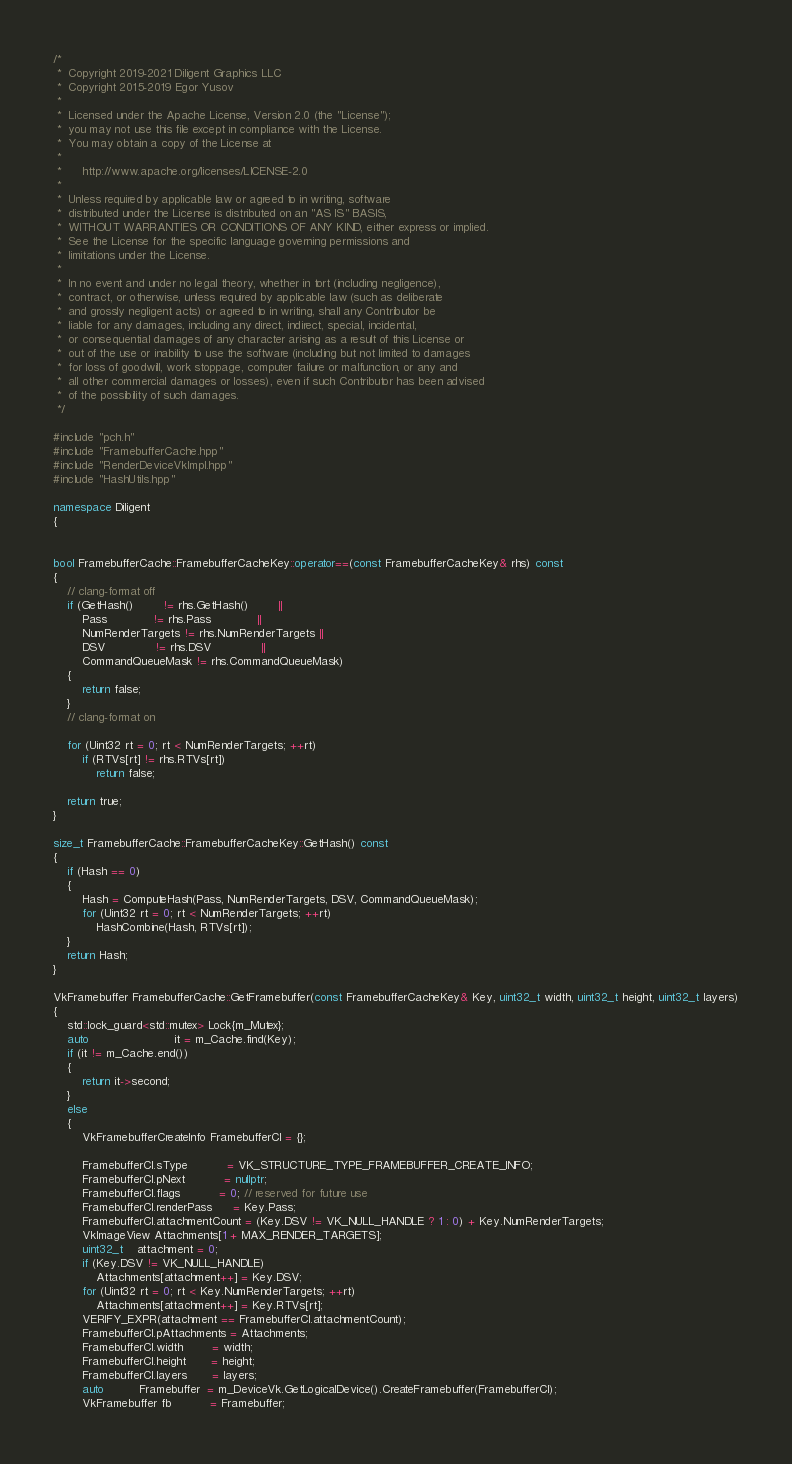Convert code to text. <code><loc_0><loc_0><loc_500><loc_500><_C++_>/*
 *  Copyright 2019-2021 Diligent Graphics LLC
 *  Copyright 2015-2019 Egor Yusov
 *  
 *  Licensed under the Apache License, Version 2.0 (the "License");
 *  you may not use this file except in compliance with the License.
 *  You may obtain a copy of the License at
 *  
 *      http://www.apache.org/licenses/LICENSE-2.0
 *  
 *  Unless required by applicable law or agreed to in writing, software
 *  distributed under the License is distributed on an "AS IS" BASIS,
 *  WITHOUT WARRANTIES OR CONDITIONS OF ANY KIND, either express or implied.
 *  See the License for the specific language governing permissions and
 *  limitations under the License.
 *
 *  In no event and under no legal theory, whether in tort (including negligence), 
 *  contract, or otherwise, unless required by applicable law (such as deliberate 
 *  and grossly negligent acts) or agreed to in writing, shall any Contributor be
 *  liable for any damages, including any direct, indirect, special, incidental, 
 *  or consequential damages of any character arising as a result of this License or 
 *  out of the use or inability to use the software (including but not limited to damages 
 *  for loss of goodwill, work stoppage, computer failure or malfunction, or any and 
 *  all other commercial damages or losses), even if such Contributor has been advised 
 *  of the possibility of such damages.
 */

#include "pch.h"
#include "FramebufferCache.hpp"
#include "RenderDeviceVkImpl.hpp"
#include "HashUtils.hpp"

namespace Diligent
{


bool FramebufferCache::FramebufferCacheKey::operator==(const FramebufferCacheKey& rhs) const
{
    // clang-format off
    if (GetHash()        != rhs.GetHash()        ||
        Pass             != rhs.Pass             ||
        NumRenderTargets != rhs.NumRenderTargets ||
        DSV              != rhs.DSV              ||
        CommandQueueMask != rhs.CommandQueueMask)
    {
        return false;
    }
    // clang-format on

    for (Uint32 rt = 0; rt < NumRenderTargets; ++rt)
        if (RTVs[rt] != rhs.RTVs[rt])
            return false;

    return true;
}

size_t FramebufferCache::FramebufferCacheKey::GetHash() const
{
    if (Hash == 0)
    {
        Hash = ComputeHash(Pass, NumRenderTargets, DSV, CommandQueueMask);
        for (Uint32 rt = 0; rt < NumRenderTargets; ++rt)
            HashCombine(Hash, RTVs[rt]);
    }
    return Hash;
}

VkFramebuffer FramebufferCache::GetFramebuffer(const FramebufferCacheKey& Key, uint32_t width, uint32_t height, uint32_t layers)
{
    std::lock_guard<std::mutex> Lock{m_Mutex};
    auto                        it = m_Cache.find(Key);
    if (it != m_Cache.end())
    {
        return it->second;
    }
    else
    {
        VkFramebufferCreateInfo FramebufferCI = {};

        FramebufferCI.sType           = VK_STRUCTURE_TYPE_FRAMEBUFFER_CREATE_INFO;
        FramebufferCI.pNext           = nullptr;
        FramebufferCI.flags           = 0; // reserved for future use
        FramebufferCI.renderPass      = Key.Pass;
        FramebufferCI.attachmentCount = (Key.DSV != VK_NULL_HANDLE ? 1 : 0) + Key.NumRenderTargets;
        VkImageView Attachments[1 + MAX_RENDER_TARGETS];
        uint32_t    attachment = 0;
        if (Key.DSV != VK_NULL_HANDLE)
            Attachments[attachment++] = Key.DSV;
        for (Uint32 rt = 0; rt < Key.NumRenderTargets; ++rt)
            Attachments[attachment++] = Key.RTVs[rt];
        VERIFY_EXPR(attachment == FramebufferCI.attachmentCount);
        FramebufferCI.pAttachments = Attachments;
        FramebufferCI.width        = width;
        FramebufferCI.height       = height;
        FramebufferCI.layers       = layers;
        auto          Framebuffer  = m_DeviceVk.GetLogicalDevice().CreateFramebuffer(FramebufferCI);
        VkFramebuffer fb           = Framebuffer;
</code> 